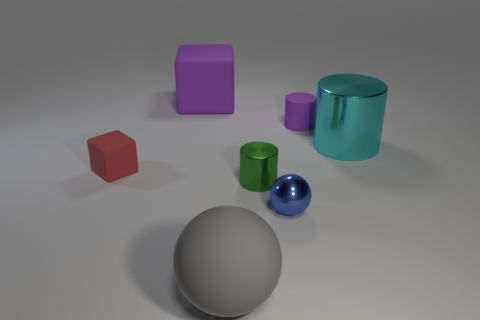Subtract all purple cylinders. How many cylinders are left? 2 Subtract 2 spheres. How many spheres are left? 0 Subtract all purple cubes. How many cubes are left? 1 Subtract all balls. How many objects are left? 5 Subtract all purple cylinders. Subtract all blue spheres. How many cylinders are left? 2 Subtract all gray blocks. How many blue spheres are left? 1 Subtract all large blue matte cylinders. Subtract all tiny green metal objects. How many objects are left? 6 Add 7 cylinders. How many cylinders are left? 10 Add 1 small purple rubber cylinders. How many small purple rubber cylinders exist? 2 Add 1 small blocks. How many objects exist? 8 